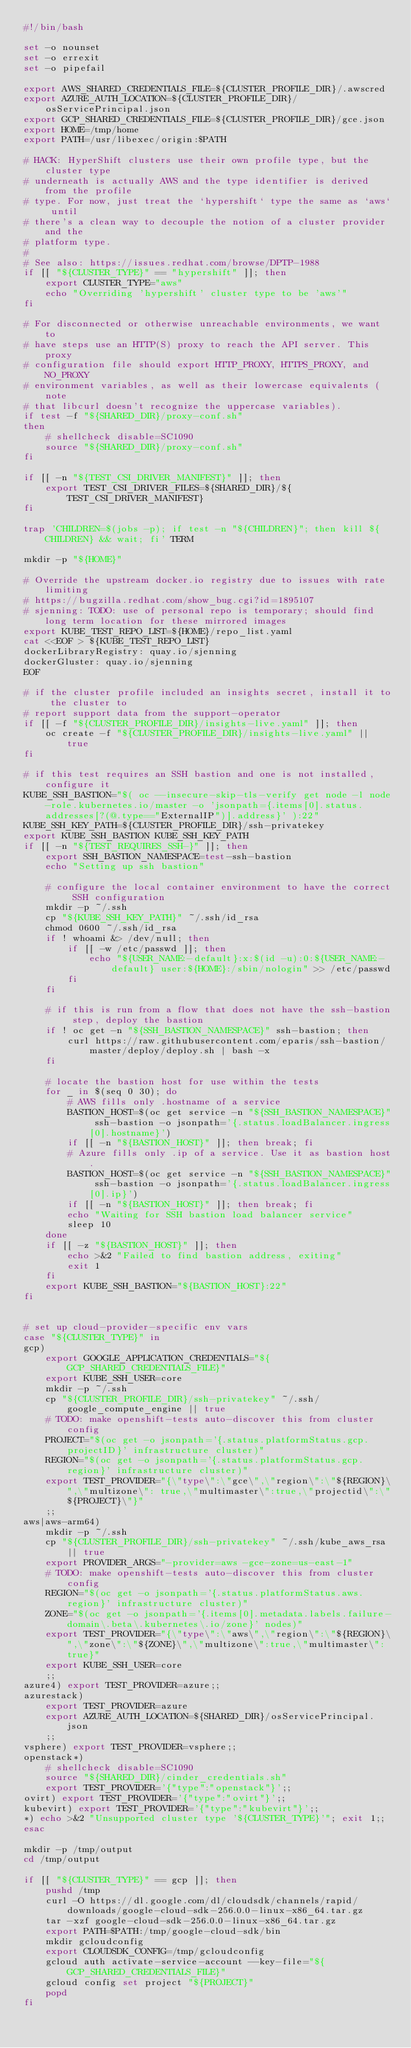<code> <loc_0><loc_0><loc_500><loc_500><_Bash_>#!/bin/bash

set -o nounset
set -o errexit
set -o pipefail

export AWS_SHARED_CREDENTIALS_FILE=${CLUSTER_PROFILE_DIR}/.awscred
export AZURE_AUTH_LOCATION=${CLUSTER_PROFILE_DIR}/osServicePrincipal.json
export GCP_SHARED_CREDENTIALS_FILE=${CLUSTER_PROFILE_DIR}/gce.json
export HOME=/tmp/home
export PATH=/usr/libexec/origin:$PATH

# HACK: HyperShift clusters use their own profile type, but the cluster type
# underneath is actually AWS and the type identifier is derived from the profile
# type. For now, just treat the `hypershift` type the same as `aws` until
# there's a clean way to decouple the notion of a cluster provider and the
# platform type.
#
# See also: https://issues.redhat.com/browse/DPTP-1988
if [[ "${CLUSTER_TYPE}" == "hypershift" ]]; then
    export CLUSTER_TYPE="aws"
    echo "Overriding 'hypershift' cluster type to be 'aws'"
fi

# For disconnected or otherwise unreachable environments, we want to
# have steps use an HTTP(S) proxy to reach the API server. This proxy
# configuration file should export HTTP_PROXY, HTTPS_PROXY, and NO_PROXY
# environment variables, as well as their lowercase equivalents (note
# that libcurl doesn't recognize the uppercase variables).
if test -f "${SHARED_DIR}/proxy-conf.sh"
then
    # shellcheck disable=SC1090
    source "${SHARED_DIR}/proxy-conf.sh"
fi

if [[ -n "${TEST_CSI_DRIVER_MANIFEST}" ]]; then
    export TEST_CSI_DRIVER_FILES=${SHARED_DIR}/${TEST_CSI_DRIVER_MANIFEST}
fi

trap 'CHILDREN=$(jobs -p); if test -n "${CHILDREN}"; then kill ${CHILDREN} && wait; fi' TERM

mkdir -p "${HOME}"

# Override the upstream docker.io registry due to issues with rate limiting
# https://bugzilla.redhat.com/show_bug.cgi?id=1895107
# sjenning: TODO: use of personal repo is temporary; should find long term location for these mirrored images
export KUBE_TEST_REPO_LIST=${HOME}/repo_list.yaml
cat <<EOF > ${KUBE_TEST_REPO_LIST}
dockerLibraryRegistry: quay.io/sjenning
dockerGluster: quay.io/sjenning
EOF

# if the cluster profile included an insights secret, install it to the cluster to
# report support data from the support-operator
if [[ -f "${CLUSTER_PROFILE_DIR}/insights-live.yaml" ]]; then
    oc create -f "${CLUSTER_PROFILE_DIR}/insights-live.yaml" || true
fi

# if this test requires an SSH bastion and one is not installed, configure it
KUBE_SSH_BASTION="$( oc --insecure-skip-tls-verify get node -l node-role.kubernetes.io/master -o 'jsonpath={.items[0].status.addresses[?(@.type=="ExternalIP")].address}' ):22"
KUBE_SSH_KEY_PATH=${CLUSTER_PROFILE_DIR}/ssh-privatekey
export KUBE_SSH_BASTION KUBE_SSH_KEY_PATH
if [[ -n "${TEST_REQUIRES_SSH-}" ]]; then
    export SSH_BASTION_NAMESPACE=test-ssh-bastion
    echo "Setting up ssh bastion"

    # configure the local container environment to have the correct SSH configuration
    mkdir -p ~/.ssh
    cp "${KUBE_SSH_KEY_PATH}" ~/.ssh/id_rsa
    chmod 0600 ~/.ssh/id_rsa
    if ! whoami &> /dev/null; then
        if [[ -w /etc/passwd ]]; then
            echo "${USER_NAME:-default}:x:$(id -u):0:${USER_NAME:-default} user:${HOME}:/sbin/nologin" >> /etc/passwd
        fi
    fi

    # if this is run from a flow that does not have the ssh-bastion step, deploy the bastion
    if ! oc get -n "${SSH_BASTION_NAMESPACE}" ssh-bastion; then
        curl https://raw.githubusercontent.com/eparis/ssh-bastion/master/deploy/deploy.sh | bash -x
    fi

    # locate the bastion host for use within the tests
    for _ in $(seq 0 30); do
        # AWS fills only .hostname of a service
        BASTION_HOST=$(oc get service -n "${SSH_BASTION_NAMESPACE}" ssh-bastion -o jsonpath='{.status.loadBalancer.ingress[0].hostname}')
        if [[ -n "${BASTION_HOST}" ]]; then break; fi
        # Azure fills only .ip of a service. Use it as bastion host.
        BASTION_HOST=$(oc get service -n "${SSH_BASTION_NAMESPACE}" ssh-bastion -o jsonpath='{.status.loadBalancer.ingress[0].ip}')
        if [[ -n "${BASTION_HOST}" ]]; then break; fi
        echo "Waiting for SSH bastion load balancer service"
        sleep 10
    done
    if [[ -z "${BASTION_HOST}" ]]; then
        echo >&2 "Failed to find bastion address, exiting"
        exit 1
    fi
    export KUBE_SSH_BASTION="${BASTION_HOST}:22"
fi


# set up cloud-provider-specific env vars
case "${CLUSTER_TYPE}" in
gcp)
    export GOOGLE_APPLICATION_CREDENTIALS="${GCP_SHARED_CREDENTIALS_FILE}"
    export KUBE_SSH_USER=core
    mkdir -p ~/.ssh
    cp "${CLUSTER_PROFILE_DIR}/ssh-privatekey" ~/.ssh/google_compute_engine || true
    # TODO: make openshift-tests auto-discover this from cluster config
    PROJECT="$(oc get -o jsonpath='{.status.platformStatus.gcp.projectID}' infrastructure cluster)"
    REGION="$(oc get -o jsonpath='{.status.platformStatus.gcp.region}' infrastructure cluster)"
    export TEST_PROVIDER="{\"type\":\"gce\",\"region\":\"${REGION}\",\"multizone\": true,\"multimaster\":true,\"projectid\":\"${PROJECT}\"}"
    ;;
aws|aws-arm64)
    mkdir -p ~/.ssh
    cp "${CLUSTER_PROFILE_DIR}/ssh-privatekey" ~/.ssh/kube_aws_rsa || true
    export PROVIDER_ARGS="-provider=aws -gce-zone=us-east-1"
    # TODO: make openshift-tests auto-discover this from cluster config
    REGION="$(oc get -o jsonpath='{.status.platformStatus.aws.region}' infrastructure cluster)"
    ZONE="$(oc get -o jsonpath='{.items[0].metadata.labels.failure-domain\.beta\.kubernetes\.io/zone}' nodes)"
    export TEST_PROVIDER="{\"type\":\"aws\",\"region\":\"${REGION}\",\"zone\":\"${ZONE}\",\"multizone\":true,\"multimaster\":true}"
    export KUBE_SSH_USER=core
    ;;
azure4) export TEST_PROVIDER=azure;;
azurestack)
    export TEST_PROVIDER=azure
    export AZURE_AUTH_LOCATION=${SHARED_DIR}/osServicePrincipal.json
    ;;
vsphere) export TEST_PROVIDER=vsphere;;
openstack*)
    # shellcheck disable=SC1090
    source "${SHARED_DIR}/cinder_credentials.sh"
    export TEST_PROVIDER='{"type":"openstack"}';;
ovirt) export TEST_PROVIDER='{"type":"ovirt"}';;
kubevirt) export TEST_PROVIDER='{"type":"kubevirt"}';;
*) echo >&2 "Unsupported cluster type '${CLUSTER_TYPE}'"; exit 1;;
esac

mkdir -p /tmp/output
cd /tmp/output

if [[ "${CLUSTER_TYPE}" == gcp ]]; then
    pushd /tmp
    curl -O https://dl.google.com/dl/cloudsdk/channels/rapid/downloads/google-cloud-sdk-256.0.0-linux-x86_64.tar.gz
    tar -xzf google-cloud-sdk-256.0.0-linux-x86_64.tar.gz
    export PATH=$PATH:/tmp/google-cloud-sdk/bin
    mkdir gcloudconfig
    export CLOUDSDK_CONFIG=/tmp/gcloudconfig
    gcloud auth activate-service-account --key-file="${GCP_SHARED_CREDENTIALS_FILE}"
    gcloud config set project "${PROJECT}"
    popd
fi
</code> 